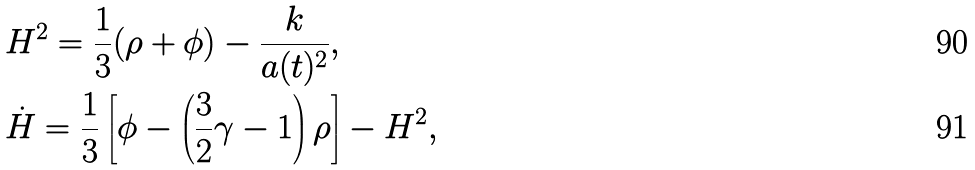<formula> <loc_0><loc_0><loc_500><loc_500>& H ^ { 2 } = \frac { 1 } { 3 } ( \rho + \phi ) - \frac { k } { a ( t ) ^ { 2 } } , \\ & \dot { H } = \frac { 1 } { 3 } \left [ \phi - \left ( \frac { 3 } { 2 } \gamma - 1 \right ) \rho \right ] - H ^ { 2 } ,</formula> 